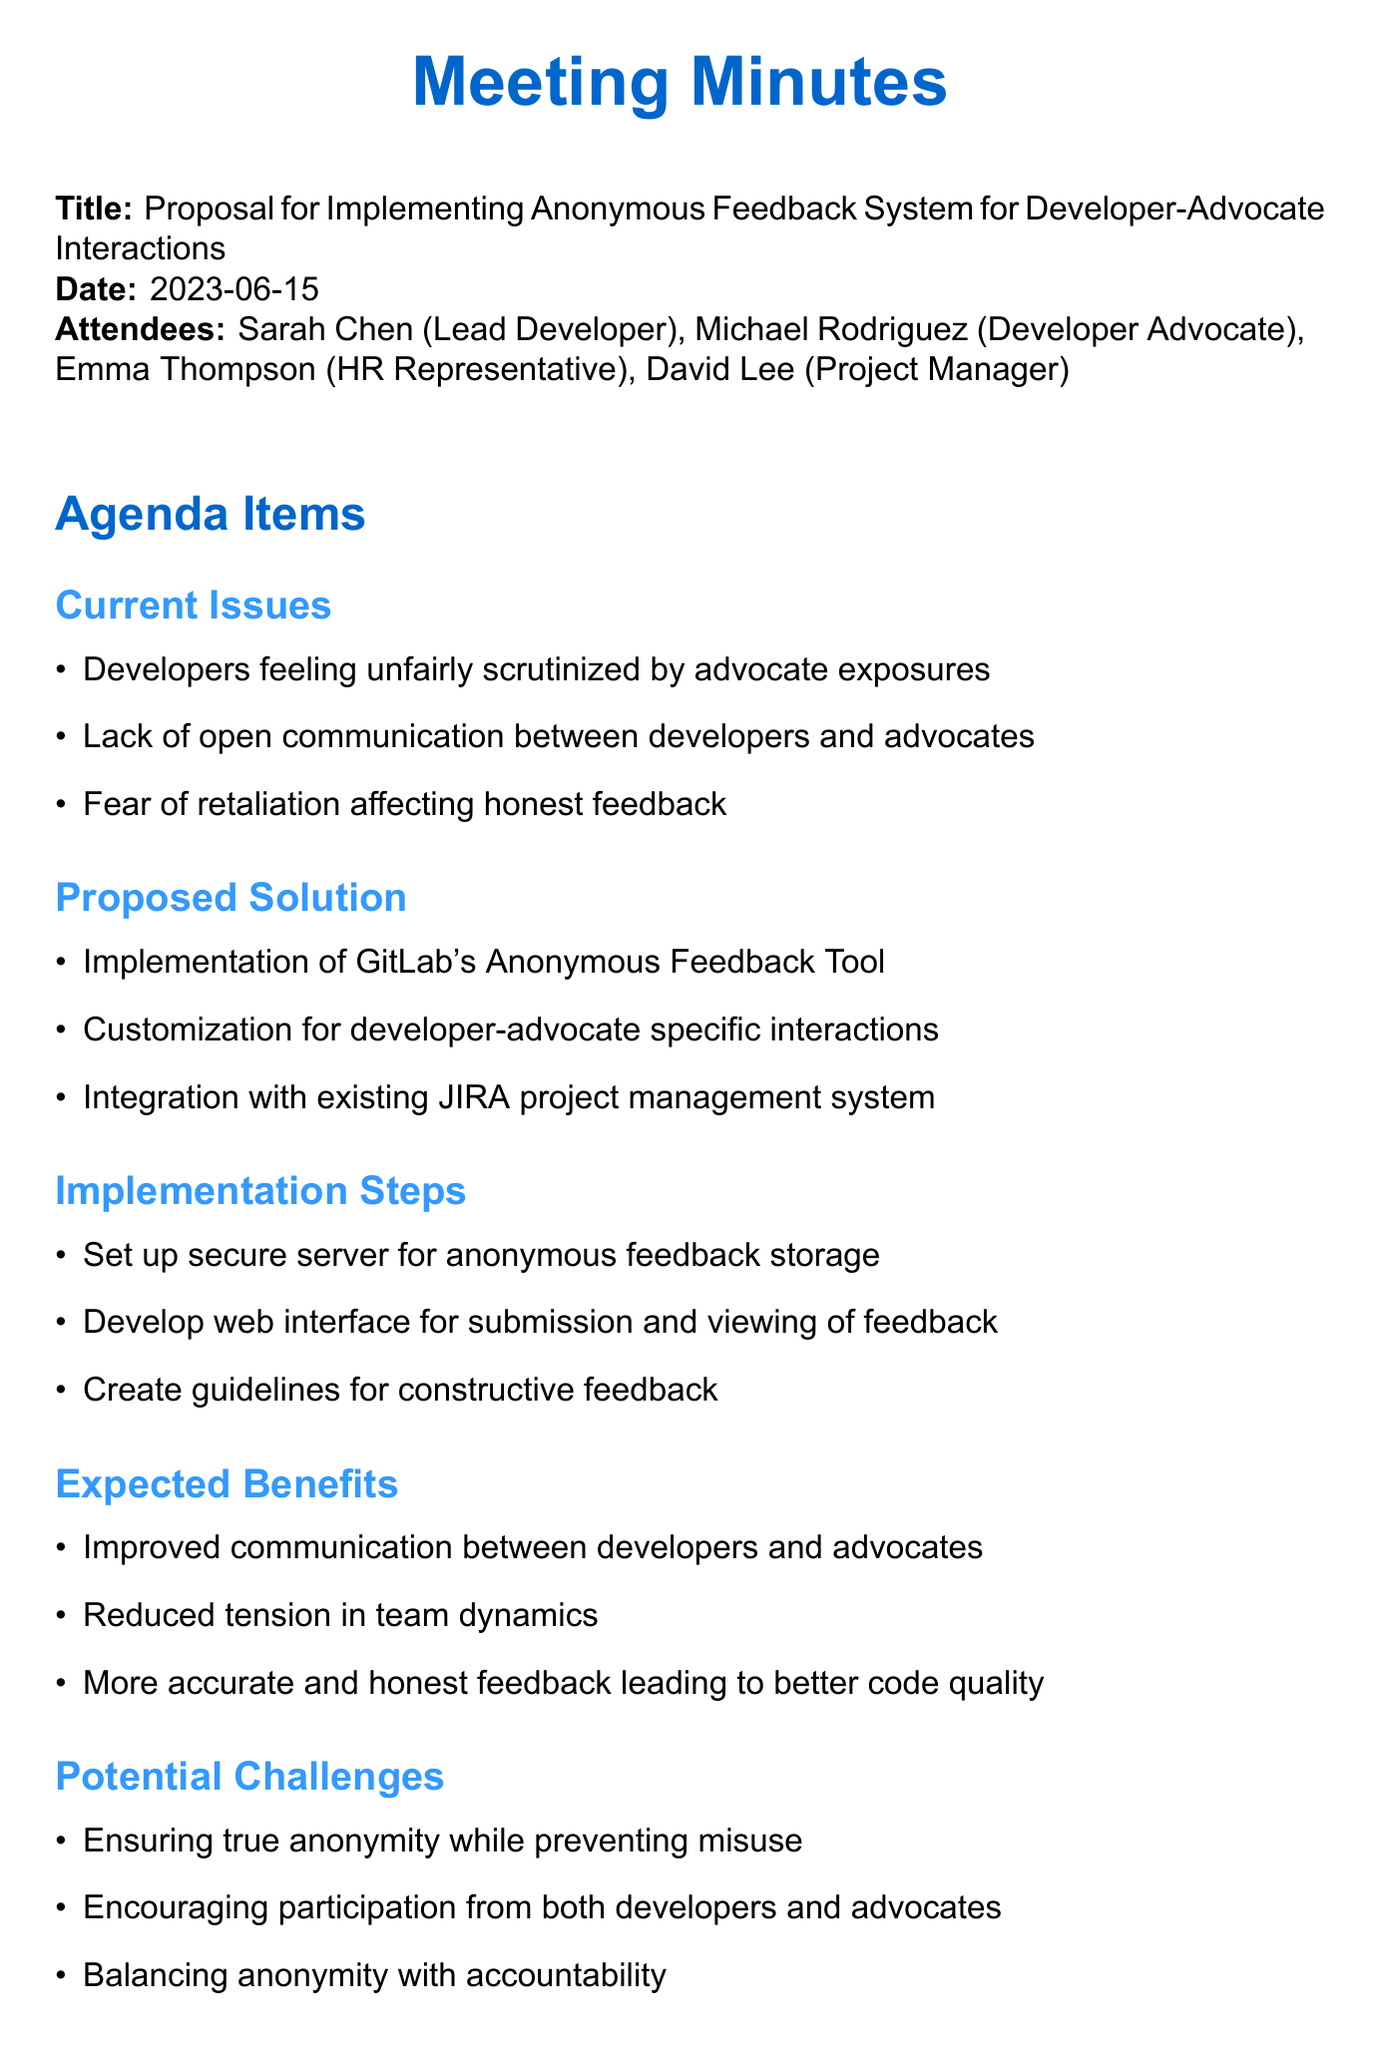What is the date of the meeting? The date of the meeting is stated at the beginning of the document.
Answer: 2023-06-15 Who is the Lead Developer? The document lists the attendees along with their roles; the Lead Developer is Sarah Chen.
Answer: Sarah Chen What is one of the current issues mentioned? Current issues are listed in the agenda, one of which is developers feeling unfairly scrutinized.
Answer: Developers feeling unfairly scrutinized by advocate exposures What tool is proposed for implementing anonymous feedback? The proposed solution section mentions the specific tool to be used for feedback.
Answer: GitLab's Anonymous Feedback Tool What is one expected benefit of the anonymous feedback system? The expected benefits section provides various advantages; one of them is improved communication.
Answer: Improved communication between developers and advocates What is a potential challenge of the anonymous feedback system? The potential challenges include various concerns; one notable challenge is ensuring true anonymity.
Answer: Ensuring true anonymity while preventing misuse How many steps are included in the implementation plan? The implementation steps section lists multiple steps; counting them provides the answer.
Answer: Three What is the next step in the plan? The next steps section outlines actions to take; one is to conduct a team survey.
Answer: Conduct team survey to gauge interest and concerns 